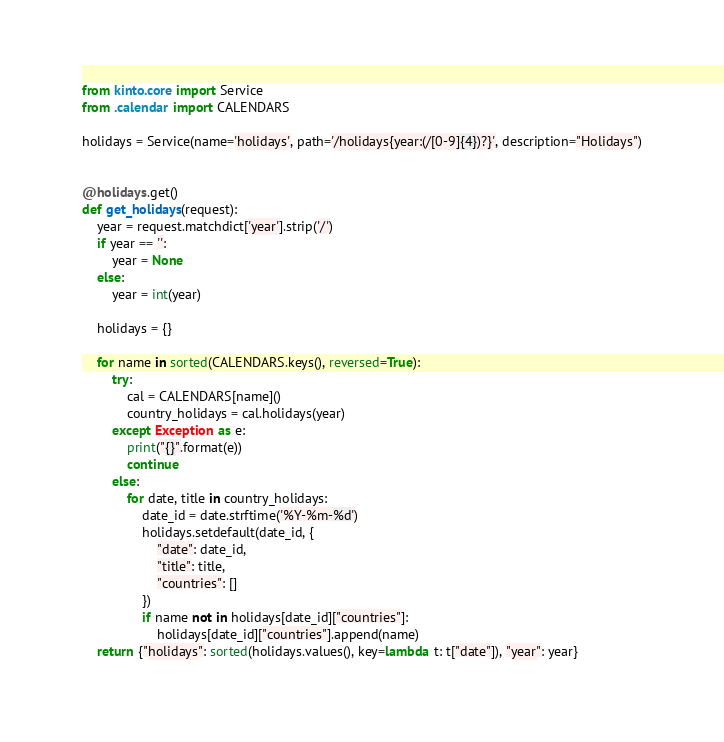<code> <loc_0><loc_0><loc_500><loc_500><_Python_>from kinto.core import Service
from .calendar import CALENDARS

holidays = Service(name='holidays', path='/holidays{year:(/[0-9]{4})?}', description="Holidays")


@holidays.get()
def get_holidays(request):
    year = request.matchdict['year'].strip('/')
    if year == '':
        year = None
    else:
        year = int(year)

    holidays = {}

    for name in sorted(CALENDARS.keys(), reversed=True):
        try:
            cal = CALENDARS[name]()
            country_holidays = cal.holidays(year)
        except Exception as e:
            print("{}".format(e))
            continue
        else:
            for date, title in country_holidays:
                date_id = date.strftime('%Y-%m-%d')
                holidays.setdefault(date_id, {
                    "date": date_id,
                    "title": title,
                    "countries": []
                })
                if name not in holidays[date_id]["countries"]:
                    holidays[date_id]["countries"].append(name)
    return {"holidays": sorted(holidays.values(), key=lambda t: t["date"]), "year": year}
</code> 